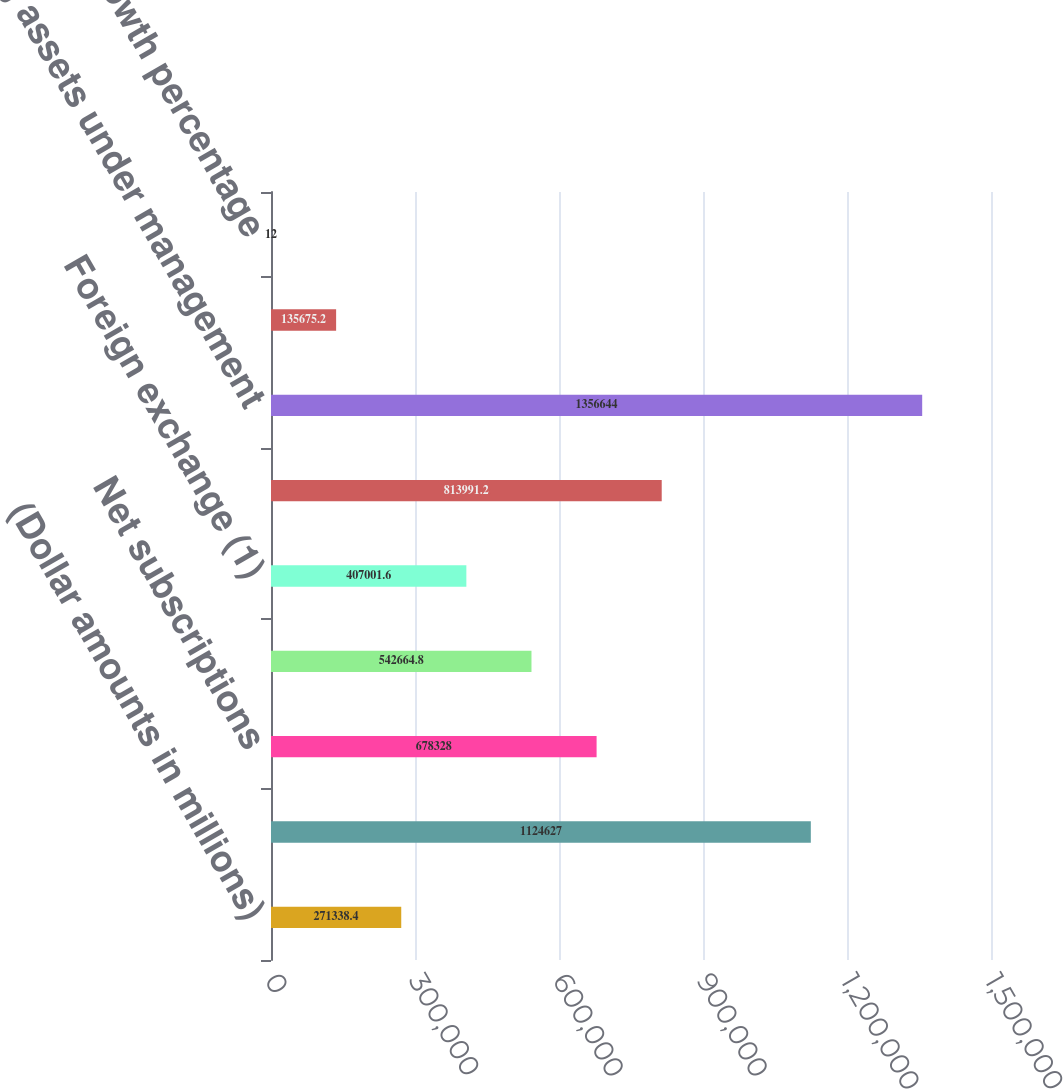Convert chart. <chart><loc_0><loc_0><loc_500><loc_500><bar_chart><fcel>(Dollar amounts in millions)<fcel>Beginning assets under<fcel>Net subscriptions<fcel>Market appreciation<fcel>Foreign exchange (1)<fcel>Total change<fcel>Ending assets under management<fcel>Percent change in total AUM<fcel>Organic growth percentage<nl><fcel>271338<fcel>1.12463e+06<fcel>678328<fcel>542665<fcel>407002<fcel>813991<fcel>1.35664e+06<fcel>135675<fcel>12<nl></chart> 